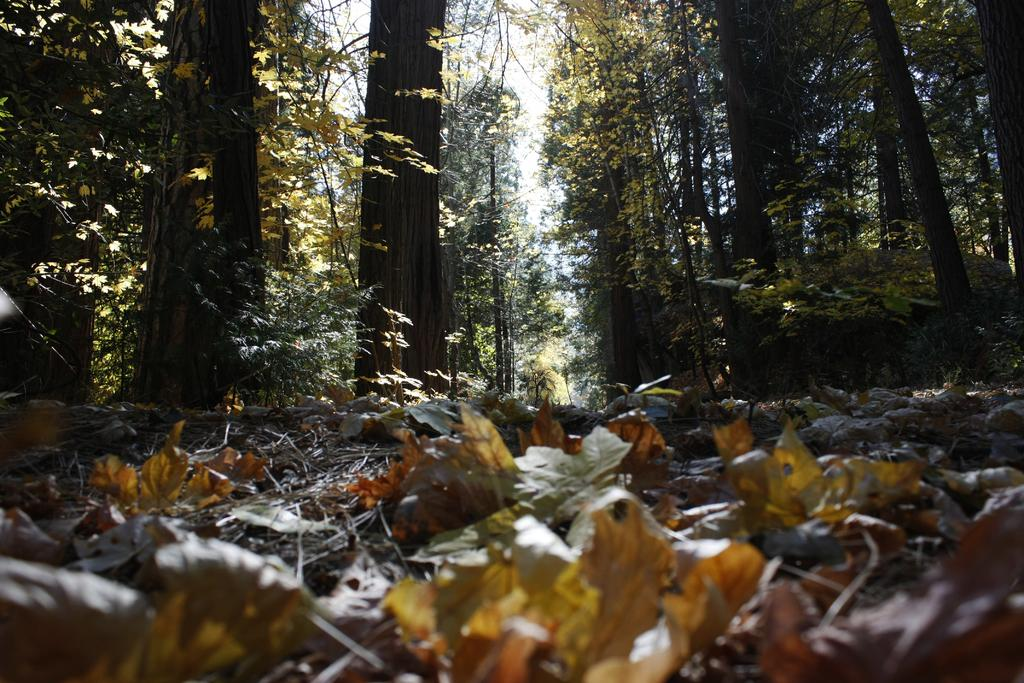What type of organic material can be seen in the image? There are shredded leaves and twigs in the image. What type of large vegetation is present in the image? There are trees in the image. What type of smaller vegetation is present in the image? There are plants in the image. What is visible in the background of the image? The sky is visible in the image. Can you see a knot tied in one of the twigs in the image? There is no mention of a knot in the image, so it cannot be determined if one is present. What rule is being enforced by the trees in the image? There is no indication of any rules being enforced by the trees in the image. 